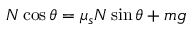<formula> <loc_0><loc_0><loc_500><loc_500>N \cos \theta = \mu _ { s } N \sin \theta + m g</formula> 